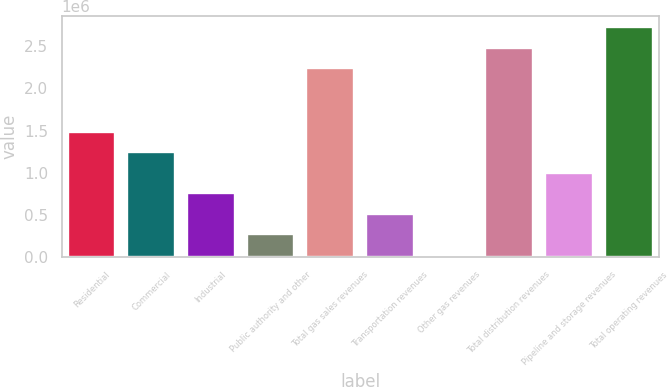Convert chart. <chart><loc_0><loc_0><loc_500><loc_500><bar_chart><fcel>Residential<fcel>Commercial<fcel>Industrial<fcel>Public authority and other<fcel>Total gas sales revenues<fcel>Transportation revenues<fcel>Other gas revenues<fcel>Total distribution revenues<fcel>Pipeline and storage revenues<fcel>Total operating revenues<nl><fcel>1.48276e+06<fcel>1.23979e+06<fcel>753852<fcel>267911<fcel>2.23677e+06<fcel>510882<fcel>24940<fcel>2.47974e+06<fcel>996823<fcel>2.72272e+06<nl></chart> 